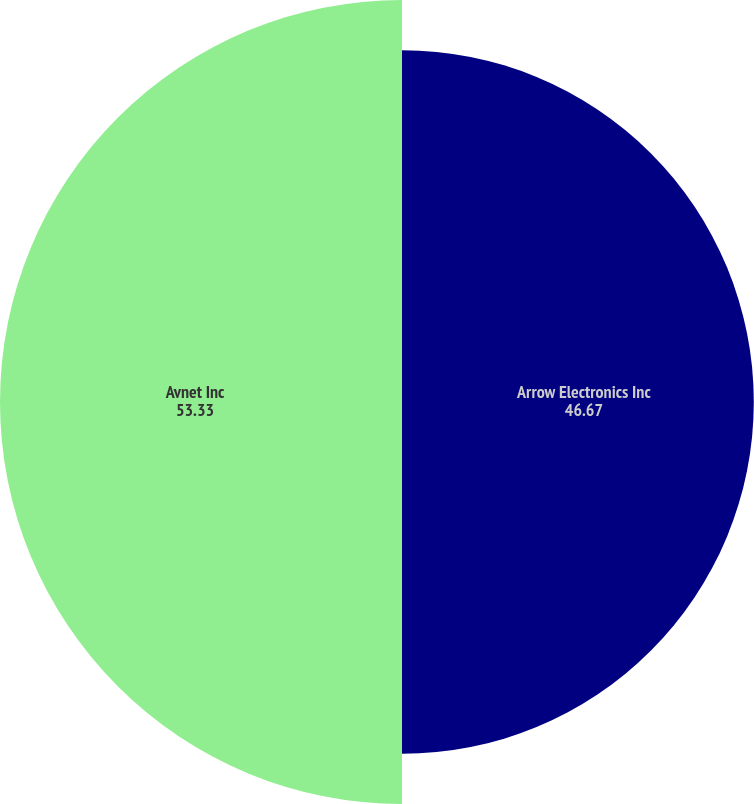Convert chart. <chart><loc_0><loc_0><loc_500><loc_500><pie_chart><fcel>Arrow Electronics Inc<fcel>Avnet Inc<nl><fcel>46.67%<fcel>53.33%<nl></chart> 